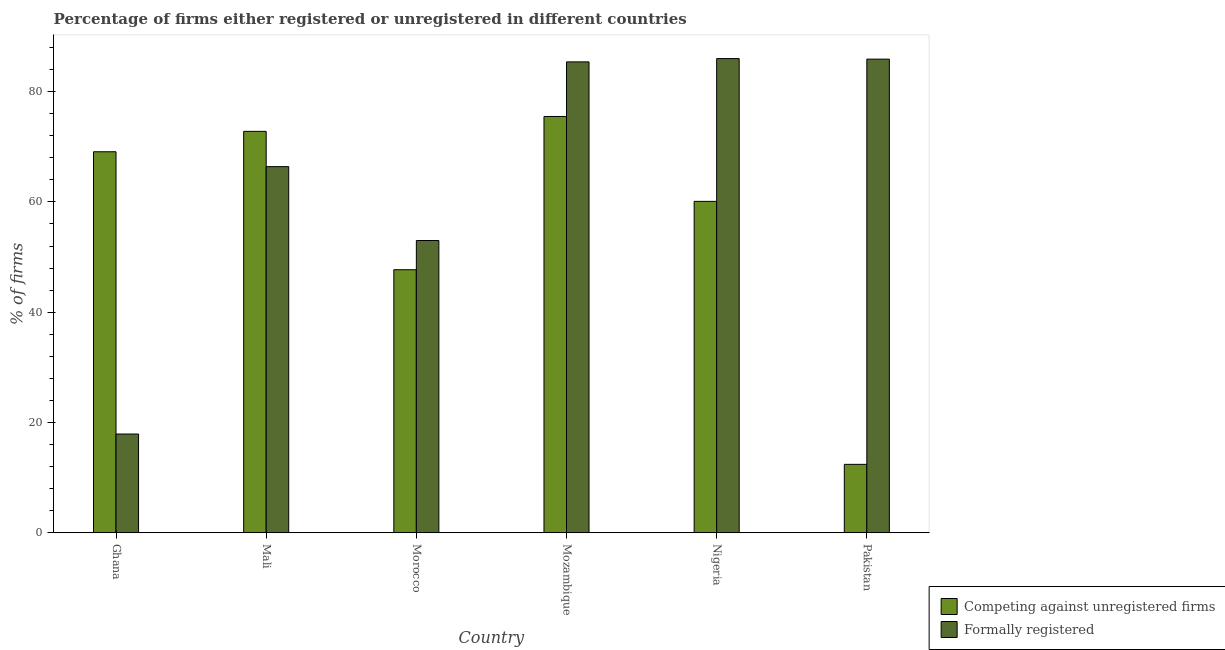How many different coloured bars are there?
Your answer should be compact. 2. Are the number of bars on each tick of the X-axis equal?
Provide a short and direct response. Yes. How many bars are there on the 1st tick from the left?
Keep it short and to the point. 2. In how many cases, is the number of bars for a given country not equal to the number of legend labels?
Provide a short and direct response. 0. What is the percentage of registered firms in Mozambique?
Provide a short and direct response. 75.5. Across all countries, what is the maximum percentage of registered firms?
Ensure brevity in your answer.  75.5. In which country was the percentage of registered firms maximum?
Keep it short and to the point. Mozambique. What is the total percentage of registered firms in the graph?
Keep it short and to the point. 337.6. What is the difference between the percentage of formally registered firms in Ghana and that in Mali?
Offer a terse response. -48.5. What is the difference between the percentage of registered firms in Morocco and the percentage of formally registered firms in Pakistan?
Provide a succinct answer. -38.2. What is the average percentage of registered firms per country?
Keep it short and to the point. 56.27. What is the difference between the percentage of formally registered firms and percentage of registered firms in Nigeria?
Provide a succinct answer. 25.9. In how many countries, is the percentage of registered firms greater than 44 %?
Provide a succinct answer. 5. What is the ratio of the percentage of registered firms in Nigeria to that in Pakistan?
Make the answer very short. 4.85. Is the percentage of registered firms in Mozambique less than that in Pakistan?
Provide a succinct answer. No. What is the difference between the highest and the second highest percentage of registered firms?
Your response must be concise. 2.7. What is the difference between the highest and the lowest percentage of registered firms?
Your answer should be compact. 63.1. Is the sum of the percentage of formally registered firms in Ghana and Mozambique greater than the maximum percentage of registered firms across all countries?
Give a very brief answer. Yes. What does the 1st bar from the left in Pakistan represents?
Your response must be concise. Competing against unregistered firms. What does the 2nd bar from the right in Nigeria represents?
Provide a succinct answer. Competing against unregistered firms. How many bars are there?
Offer a terse response. 12. What is the difference between two consecutive major ticks on the Y-axis?
Offer a terse response. 20. Does the graph contain grids?
Give a very brief answer. No. How many legend labels are there?
Give a very brief answer. 2. How are the legend labels stacked?
Offer a terse response. Vertical. What is the title of the graph?
Provide a succinct answer. Percentage of firms either registered or unregistered in different countries. What is the label or title of the Y-axis?
Your response must be concise. % of firms. What is the % of firms in Competing against unregistered firms in Ghana?
Ensure brevity in your answer.  69.1. What is the % of firms of Competing against unregistered firms in Mali?
Your response must be concise. 72.8. What is the % of firms of Formally registered in Mali?
Provide a short and direct response. 66.4. What is the % of firms in Competing against unregistered firms in Morocco?
Provide a succinct answer. 47.7. What is the % of firms of Formally registered in Morocco?
Provide a succinct answer. 53. What is the % of firms in Competing against unregistered firms in Mozambique?
Ensure brevity in your answer.  75.5. What is the % of firms of Formally registered in Mozambique?
Make the answer very short. 85.4. What is the % of firms in Competing against unregistered firms in Nigeria?
Give a very brief answer. 60.1. What is the % of firms of Competing against unregistered firms in Pakistan?
Make the answer very short. 12.4. What is the % of firms in Formally registered in Pakistan?
Offer a terse response. 85.9. Across all countries, what is the maximum % of firms in Competing against unregistered firms?
Keep it short and to the point. 75.5. Across all countries, what is the maximum % of firms of Formally registered?
Give a very brief answer. 86. Across all countries, what is the minimum % of firms in Formally registered?
Make the answer very short. 17.9. What is the total % of firms in Competing against unregistered firms in the graph?
Your response must be concise. 337.6. What is the total % of firms of Formally registered in the graph?
Offer a terse response. 394.6. What is the difference between the % of firms of Formally registered in Ghana and that in Mali?
Your answer should be very brief. -48.5. What is the difference between the % of firms in Competing against unregistered firms in Ghana and that in Morocco?
Keep it short and to the point. 21.4. What is the difference between the % of firms in Formally registered in Ghana and that in Morocco?
Provide a succinct answer. -35.1. What is the difference between the % of firms of Competing against unregistered firms in Ghana and that in Mozambique?
Make the answer very short. -6.4. What is the difference between the % of firms in Formally registered in Ghana and that in Mozambique?
Provide a succinct answer. -67.5. What is the difference between the % of firms of Formally registered in Ghana and that in Nigeria?
Provide a succinct answer. -68.1. What is the difference between the % of firms in Competing against unregistered firms in Ghana and that in Pakistan?
Your answer should be very brief. 56.7. What is the difference between the % of firms of Formally registered in Ghana and that in Pakistan?
Offer a very short reply. -68. What is the difference between the % of firms in Competing against unregistered firms in Mali and that in Morocco?
Your answer should be compact. 25.1. What is the difference between the % of firms of Formally registered in Mali and that in Morocco?
Keep it short and to the point. 13.4. What is the difference between the % of firms of Competing against unregistered firms in Mali and that in Mozambique?
Your response must be concise. -2.7. What is the difference between the % of firms in Formally registered in Mali and that in Mozambique?
Make the answer very short. -19. What is the difference between the % of firms in Formally registered in Mali and that in Nigeria?
Provide a succinct answer. -19.6. What is the difference between the % of firms of Competing against unregistered firms in Mali and that in Pakistan?
Your answer should be very brief. 60.4. What is the difference between the % of firms in Formally registered in Mali and that in Pakistan?
Offer a terse response. -19.5. What is the difference between the % of firms of Competing against unregistered firms in Morocco and that in Mozambique?
Offer a very short reply. -27.8. What is the difference between the % of firms in Formally registered in Morocco and that in Mozambique?
Make the answer very short. -32.4. What is the difference between the % of firms of Competing against unregistered firms in Morocco and that in Nigeria?
Provide a short and direct response. -12.4. What is the difference between the % of firms in Formally registered in Morocco and that in Nigeria?
Your response must be concise. -33. What is the difference between the % of firms of Competing against unregistered firms in Morocco and that in Pakistan?
Ensure brevity in your answer.  35.3. What is the difference between the % of firms in Formally registered in Morocco and that in Pakistan?
Provide a succinct answer. -32.9. What is the difference between the % of firms in Competing against unregistered firms in Mozambique and that in Pakistan?
Your answer should be compact. 63.1. What is the difference between the % of firms in Competing against unregistered firms in Nigeria and that in Pakistan?
Ensure brevity in your answer.  47.7. What is the difference between the % of firms in Competing against unregistered firms in Ghana and the % of firms in Formally registered in Mali?
Your response must be concise. 2.7. What is the difference between the % of firms in Competing against unregistered firms in Ghana and the % of firms in Formally registered in Mozambique?
Ensure brevity in your answer.  -16.3. What is the difference between the % of firms of Competing against unregistered firms in Ghana and the % of firms of Formally registered in Nigeria?
Your answer should be very brief. -16.9. What is the difference between the % of firms of Competing against unregistered firms in Ghana and the % of firms of Formally registered in Pakistan?
Make the answer very short. -16.8. What is the difference between the % of firms in Competing against unregistered firms in Mali and the % of firms in Formally registered in Morocco?
Offer a terse response. 19.8. What is the difference between the % of firms of Competing against unregistered firms in Mali and the % of firms of Formally registered in Nigeria?
Keep it short and to the point. -13.2. What is the difference between the % of firms of Competing against unregistered firms in Mali and the % of firms of Formally registered in Pakistan?
Your answer should be very brief. -13.1. What is the difference between the % of firms of Competing against unregistered firms in Morocco and the % of firms of Formally registered in Mozambique?
Offer a terse response. -37.7. What is the difference between the % of firms of Competing against unregistered firms in Morocco and the % of firms of Formally registered in Nigeria?
Provide a succinct answer. -38.3. What is the difference between the % of firms of Competing against unregistered firms in Morocco and the % of firms of Formally registered in Pakistan?
Offer a terse response. -38.2. What is the difference between the % of firms in Competing against unregistered firms in Nigeria and the % of firms in Formally registered in Pakistan?
Keep it short and to the point. -25.8. What is the average % of firms in Competing against unregistered firms per country?
Offer a very short reply. 56.27. What is the average % of firms of Formally registered per country?
Your answer should be very brief. 65.77. What is the difference between the % of firms in Competing against unregistered firms and % of firms in Formally registered in Ghana?
Provide a short and direct response. 51.2. What is the difference between the % of firms in Competing against unregistered firms and % of firms in Formally registered in Morocco?
Your answer should be very brief. -5.3. What is the difference between the % of firms in Competing against unregistered firms and % of firms in Formally registered in Nigeria?
Provide a succinct answer. -25.9. What is the difference between the % of firms in Competing against unregistered firms and % of firms in Formally registered in Pakistan?
Provide a short and direct response. -73.5. What is the ratio of the % of firms in Competing against unregistered firms in Ghana to that in Mali?
Your answer should be very brief. 0.95. What is the ratio of the % of firms in Formally registered in Ghana to that in Mali?
Ensure brevity in your answer.  0.27. What is the ratio of the % of firms of Competing against unregistered firms in Ghana to that in Morocco?
Your response must be concise. 1.45. What is the ratio of the % of firms of Formally registered in Ghana to that in Morocco?
Your answer should be compact. 0.34. What is the ratio of the % of firms in Competing against unregistered firms in Ghana to that in Mozambique?
Give a very brief answer. 0.92. What is the ratio of the % of firms of Formally registered in Ghana to that in Mozambique?
Your answer should be very brief. 0.21. What is the ratio of the % of firms in Competing against unregistered firms in Ghana to that in Nigeria?
Your response must be concise. 1.15. What is the ratio of the % of firms in Formally registered in Ghana to that in Nigeria?
Your answer should be very brief. 0.21. What is the ratio of the % of firms in Competing against unregistered firms in Ghana to that in Pakistan?
Ensure brevity in your answer.  5.57. What is the ratio of the % of firms of Formally registered in Ghana to that in Pakistan?
Offer a very short reply. 0.21. What is the ratio of the % of firms in Competing against unregistered firms in Mali to that in Morocco?
Give a very brief answer. 1.53. What is the ratio of the % of firms of Formally registered in Mali to that in Morocco?
Offer a terse response. 1.25. What is the ratio of the % of firms in Competing against unregistered firms in Mali to that in Mozambique?
Your response must be concise. 0.96. What is the ratio of the % of firms of Formally registered in Mali to that in Mozambique?
Ensure brevity in your answer.  0.78. What is the ratio of the % of firms in Competing against unregistered firms in Mali to that in Nigeria?
Make the answer very short. 1.21. What is the ratio of the % of firms in Formally registered in Mali to that in Nigeria?
Give a very brief answer. 0.77. What is the ratio of the % of firms of Competing against unregistered firms in Mali to that in Pakistan?
Offer a very short reply. 5.87. What is the ratio of the % of firms of Formally registered in Mali to that in Pakistan?
Ensure brevity in your answer.  0.77. What is the ratio of the % of firms in Competing against unregistered firms in Morocco to that in Mozambique?
Ensure brevity in your answer.  0.63. What is the ratio of the % of firms in Formally registered in Morocco to that in Mozambique?
Offer a very short reply. 0.62. What is the ratio of the % of firms of Competing against unregistered firms in Morocco to that in Nigeria?
Ensure brevity in your answer.  0.79. What is the ratio of the % of firms in Formally registered in Morocco to that in Nigeria?
Your answer should be very brief. 0.62. What is the ratio of the % of firms of Competing against unregistered firms in Morocco to that in Pakistan?
Provide a succinct answer. 3.85. What is the ratio of the % of firms in Formally registered in Morocco to that in Pakistan?
Your answer should be compact. 0.62. What is the ratio of the % of firms in Competing against unregistered firms in Mozambique to that in Nigeria?
Your answer should be very brief. 1.26. What is the ratio of the % of firms of Competing against unregistered firms in Mozambique to that in Pakistan?
Your answer should be compact. 6.09. What is the ratio of the % of firms in Competing against unregistered firms in Nigeria to that in Pakistan?
Your response must be concise. 4.85. What is the difference between the highest and the second highest % of firms of Competing against unregistered firms?
Ensure brevity in your answer.  2.7. What is the difference between the highest and the lowest % of firms of Competing against unregistered firms?
Offer a terse response. 63.1. What is the difference between the highest and the lowest % of firms of Formally registered?
Keep it short and to the point. 68.1. 